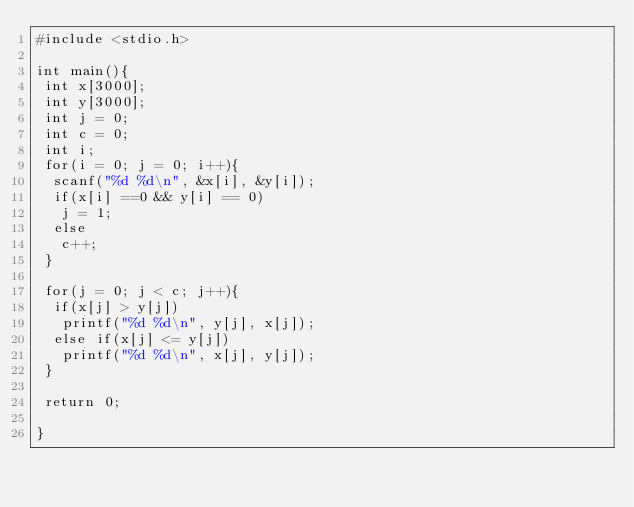<code> <loc_0><loc_0><loc_500><loc_500><_C_>#include <stdio.h>

int main(){
 int x[3000];
 int y[3000];
 int j = 0;
 int c = 0;
 int i;
 for(i = 0; j = 0; i++){
  scanf("%d %d\n", &x[i], &y[i]);
  if(x[i] ==0 && y[i] == 0)
   j = 1;
  else
   c++;
 }

 for(j = 0; j < c; j++){
  if(x[j] > y[j])
   printf("%d %d\n", y[j], x[j]);
  else if(x[j] <= y[j])
   printf("%d %d\n", x[j], y[j]);
 }

 return 0;

}</code> 